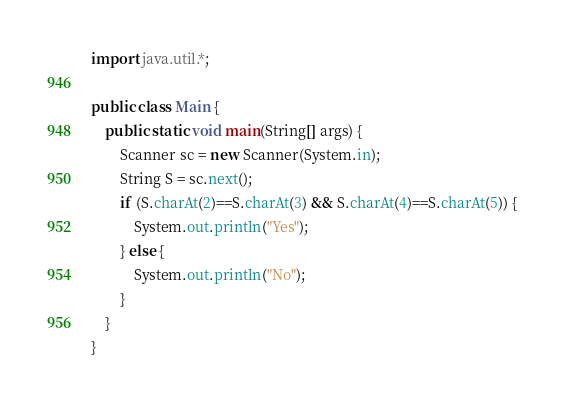Convert code to text. <code><loc_0><loc_0><loc_500><loc_500><_Java_>import java.util.*;

public class Main {
    public static void main(String[] args) {
        Scanner sc = new Scanner(System.in);
        String S = sc.next();
        if (S.charAt(2)==S.charAt(3) && S.charAt(4)==S.charAt(5)) {
            System.out.println("Yes");
        } else {
            System.out.println("No");
        }
    }
}</code> 